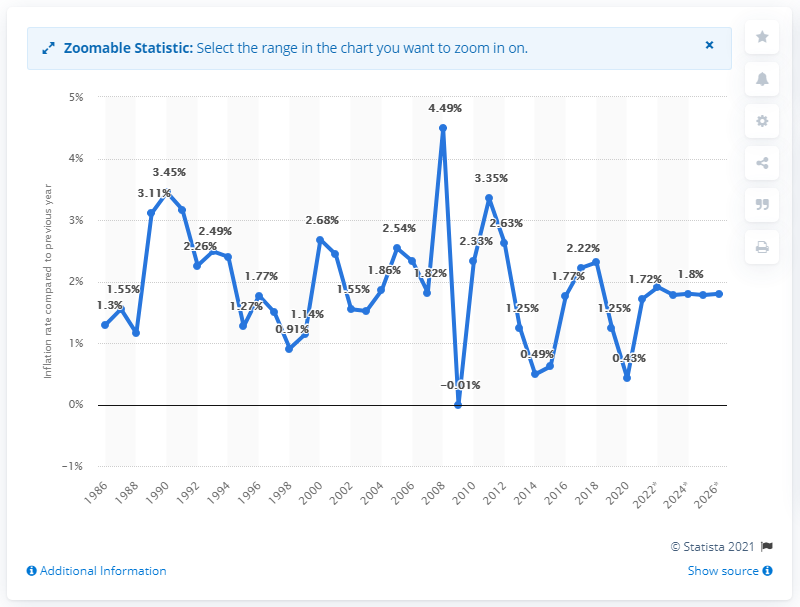Specify some key components in this picture. In 2020, the inflation rate in Belgium was 0.43%. 